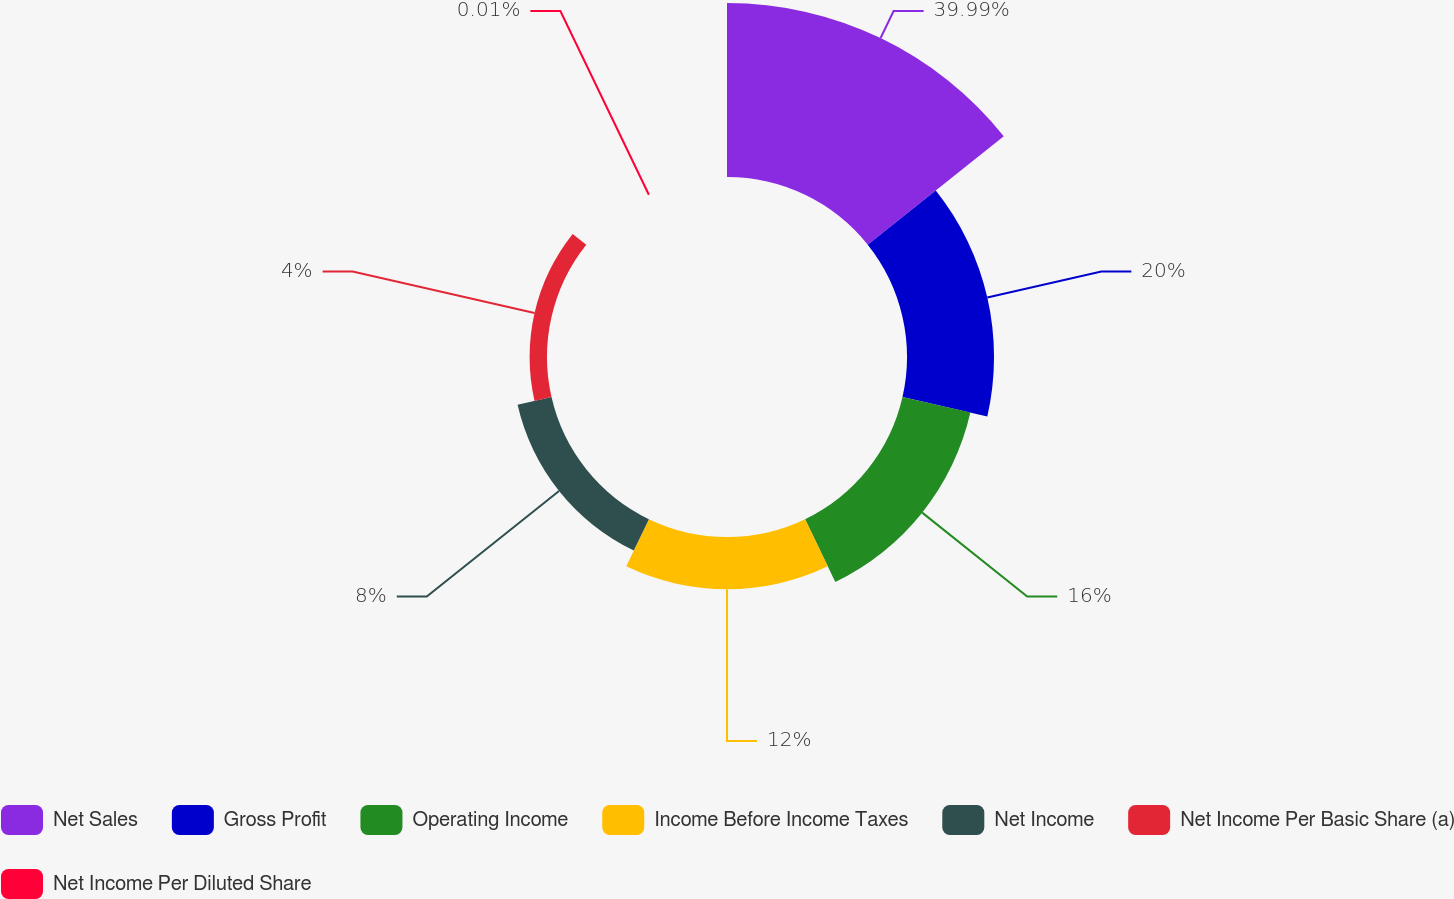<chart> <loc_0><loc_0><loc_500><loc_500><pie_chart><fcel>Net Sales<fcel>Gross Profit<fcel>Operating Income<fcel>Income Before Income Taxes<fcel>Net Income<fcel>Net Income Per Basic Share (a)<fcel>Net Income Per Diluted Share<nl><fcel>39.99%<fcel>20.0%<fcel>16.0%<fcel>12.0%<fcel>8.0%<fcel>4.0%<fcel>0.01%<nl></chart> 